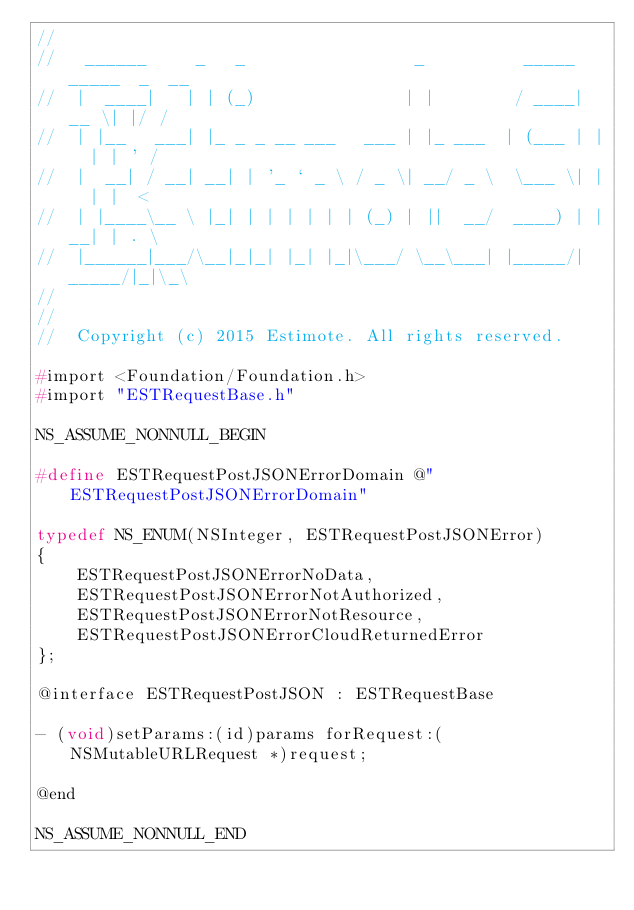<code> <loc_0><loc_0><loc_500><loc_500><_C_>//
//   ______     _   _                 _          _____ _____  _  __
//  |  ____|   | | (_)               | |        / ____|  __ \| |/ /
//  | |__   ___| |_ _ _ __ ___   ___ | |_ ___  | (___ | |  | | ' /
//  |  __| / __| __| | '_ ` _ \ / _ \| __/ _ \  \___ \| |  | |  <
//  | |____\__ \ |_| | | | | | | (_) | ||  __/  ____) | |__| | . \
//  |______|___/\__|_|_| |_| |_|\___/ \__\___| |_____/|_____/|_|\_\
//
//
//  Copyright (c) 2015 Estimote. All rights reserved.

#import <Foundation/Foundation.h>
#import "ESTRequestBase.h"

NS_ASSUME_NONNULL_BEGIN

#define ESTRequestPostJSONErrorDomain @"ESTRequestPostJSONErrorDomain"

typedef NS_ENUM(NSInteger, ESTRequestPostJSONError)
{
    ESTRequestPostJSONErrorNoData,
    ESTRequestPostJSONErrorNotAuthorized,
    ESTRequestPostJSONErrorNotResource,
    ESTRequestPostJSONErrorCloudReturnedError
};

@interface ESTRequestPostJSON : ESTRequestBase

- (void)setParams:(id)params forRequest:(NSMutableURLRequest *)request;

@end

NS_ASSUME_NONNULL_END
</code> 